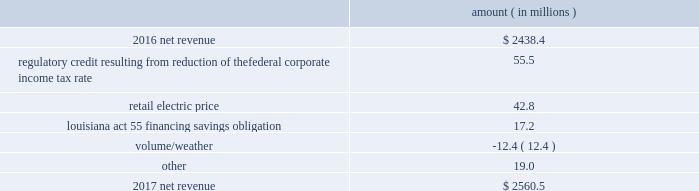Entergy louisiana , llc and subsidiaries management 2019s financial discussion and analysis results of operations net income 2017 compared to 2016 net income decreased $ 305.7 million primarily due to the effect of the enactment of the tax cuts and jobs act , in december 2017 , which resulted in a decrease of $ 182.6 million in net income in 2017 , and the effect of a settlement with the irs related to the 2010-2011 irs audit , which resulted in a $ 136.1 million reduction of income tax expense in 2016 .
Also contributing to the decrease in net income were higher other operation and maintenance expenses .
The decrease was partially offset by higher net revenue and higher other income .
See note 3 to the financial statements for discussion of the effects of the tax cuts and jobs act and the irs audit .
2016 compared to 2015 net income increased $ 175.4 million primarily due to the effect of a settlement with the irs related to the 2010-2011 irs audit , which resulted in a $ 136.1 million reduction of income tax expense in 2016 .
Also contributing to the increase were lower other operation and maintenance expenses , higher net revenue , and higher other income .
The increase was partially offset by higher depreciation and amortization expenses , higher interest expense , and higher nuclear refueling outage expenses .
See note 3 to the financial statements for discussion of the irs audit .
Net revenue 2017 compared to 2016 net revenue consists of operating revenues net of : 1 ) fuel , fuel-related expenses , and gas purchased for resale , 2 ) purchased power expenses , and 3 ) other regulatory charges ( credits ) .
Following is an analysis of the change in net revenue comparing 2017 to 2016 .
Amount ( in millions ) .
The regulatory credit resulting from reduction of the federal corporate income tax rate variance is due to the reduction of the vidalia purchased power agreement regulatory liability by $ 30.5 million and the reduction of the louisiana act 55 financing savings obligation regulatory liabilities by $ 25 million as a result of the enactment of the tax cuts and jobs act , in december 2017 , which lowered the federal corporate income tax rate from 35% ( 35 % ) to 21% ( 21 % ) .
The effects of the tax cuts and jobs act are discussed further in note 3 to the financial statements. .
In 2016 , what percent of the increase in net income is from the decrease of tax? 
Computations: (136.1 / 175.4)
Answer: 0.77594. 